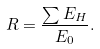Convert formula to latex. <formula><loc_0><loc_0><loc_500><loc_500>R = \frac { \sum E _ { H } } { E _ { 0 } } .</formula> 